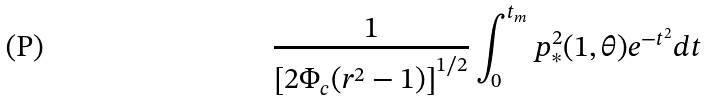Convert formula to latex. <formula><loc_0><loc_0><loc_500><loc_500>\frac { 1 } { \left [ 2 \Phi _ { c } ( r ^ { 2 } - 1 ) \right ] ^ { 1 / 2 } } \int _ { 0 } ^ { t _ { m } } p _ { \ast } ^ { 2 } ( 1 , \theta ) e ^ { - t ^ { 2 } } d t</formula> 